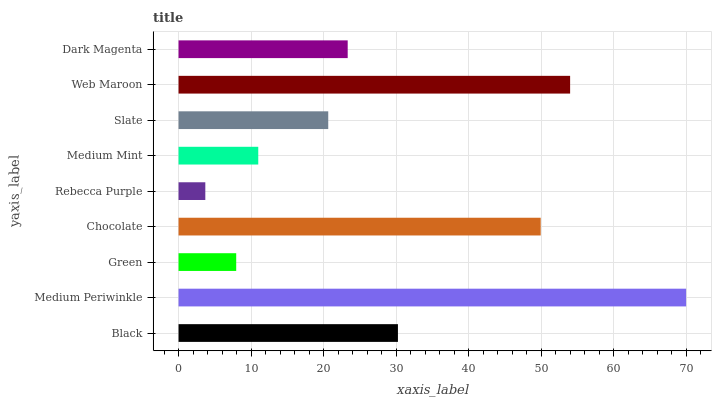Is Rebecca Purple the minimum?
Answer yes or no. Yes. Is Medium Periwinkle the maximum?
Answer yes or no. Yes. Is Green the minimum?
Answer yes or no. No. Is Green the maximum?
Answer yes or no. No. Is Medium Periwinkle greater than Green?
Answer yes or no. Yes. Is Green less than Medium Periwinkle?
Answer yes or no. Yes. Is Green greater than Medium Periwinkle?
Answer yes or no. No. Is Medium Periwinkle less than Green?
Answer yes or no. No. Is Dark Magenta the high median?
Answer yes or no. Yes. Is Dark Magenta the low median?
Answer yes or no. Yes. Is Medium Mint the high median?
Answer yes or no. No. Is Web Maroon the low median?
Answer yes or no. No. 